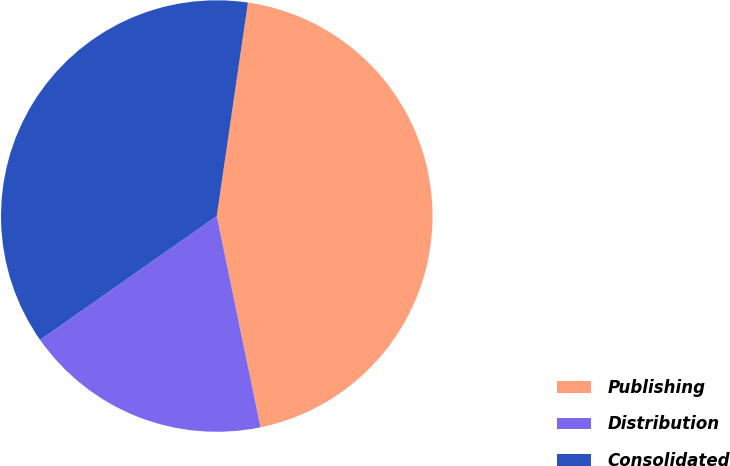<chart> <loc_0><loc_0><loc_500><loc_500><pie_chart><fcel>Publishing<fcel>Distribution<fcel>Consolidated<nl><fcel>44.44%<fcel>18.52%<fcel>37.04%<nl></chart> 